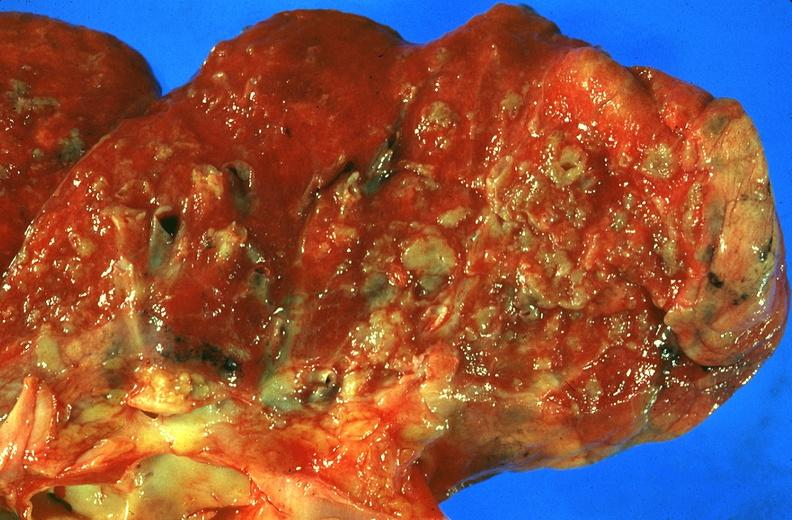what is present?
Answer the question using a single word or phrase. Respiratory 